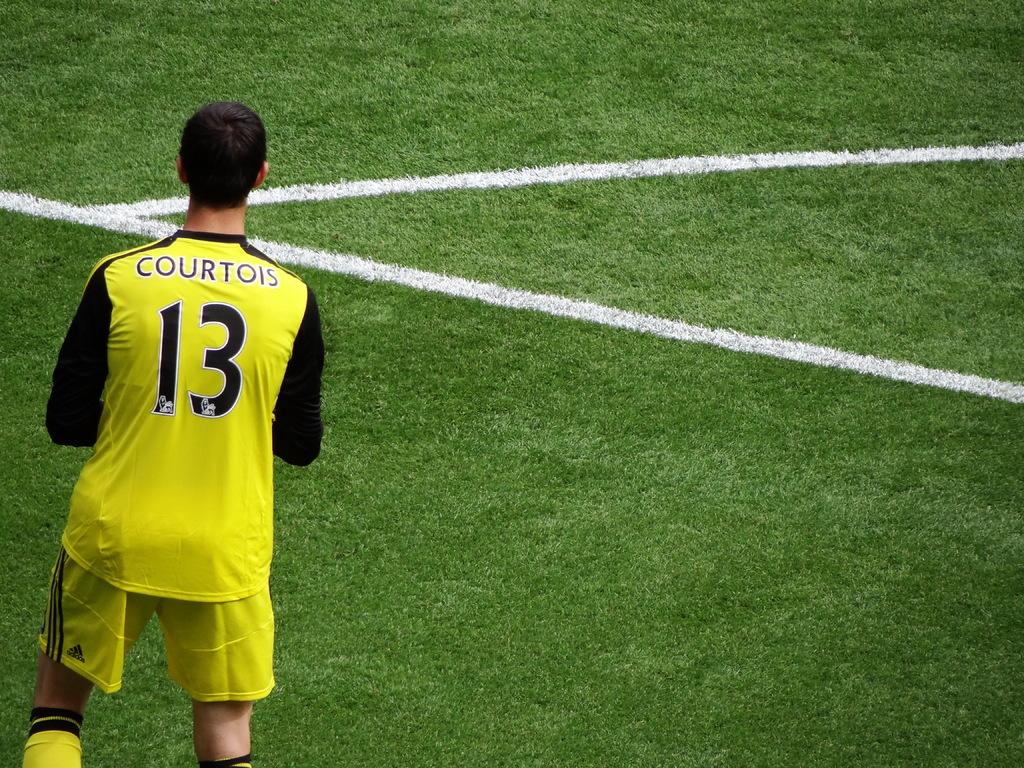What is the number?
Offer a terse response. 13. 